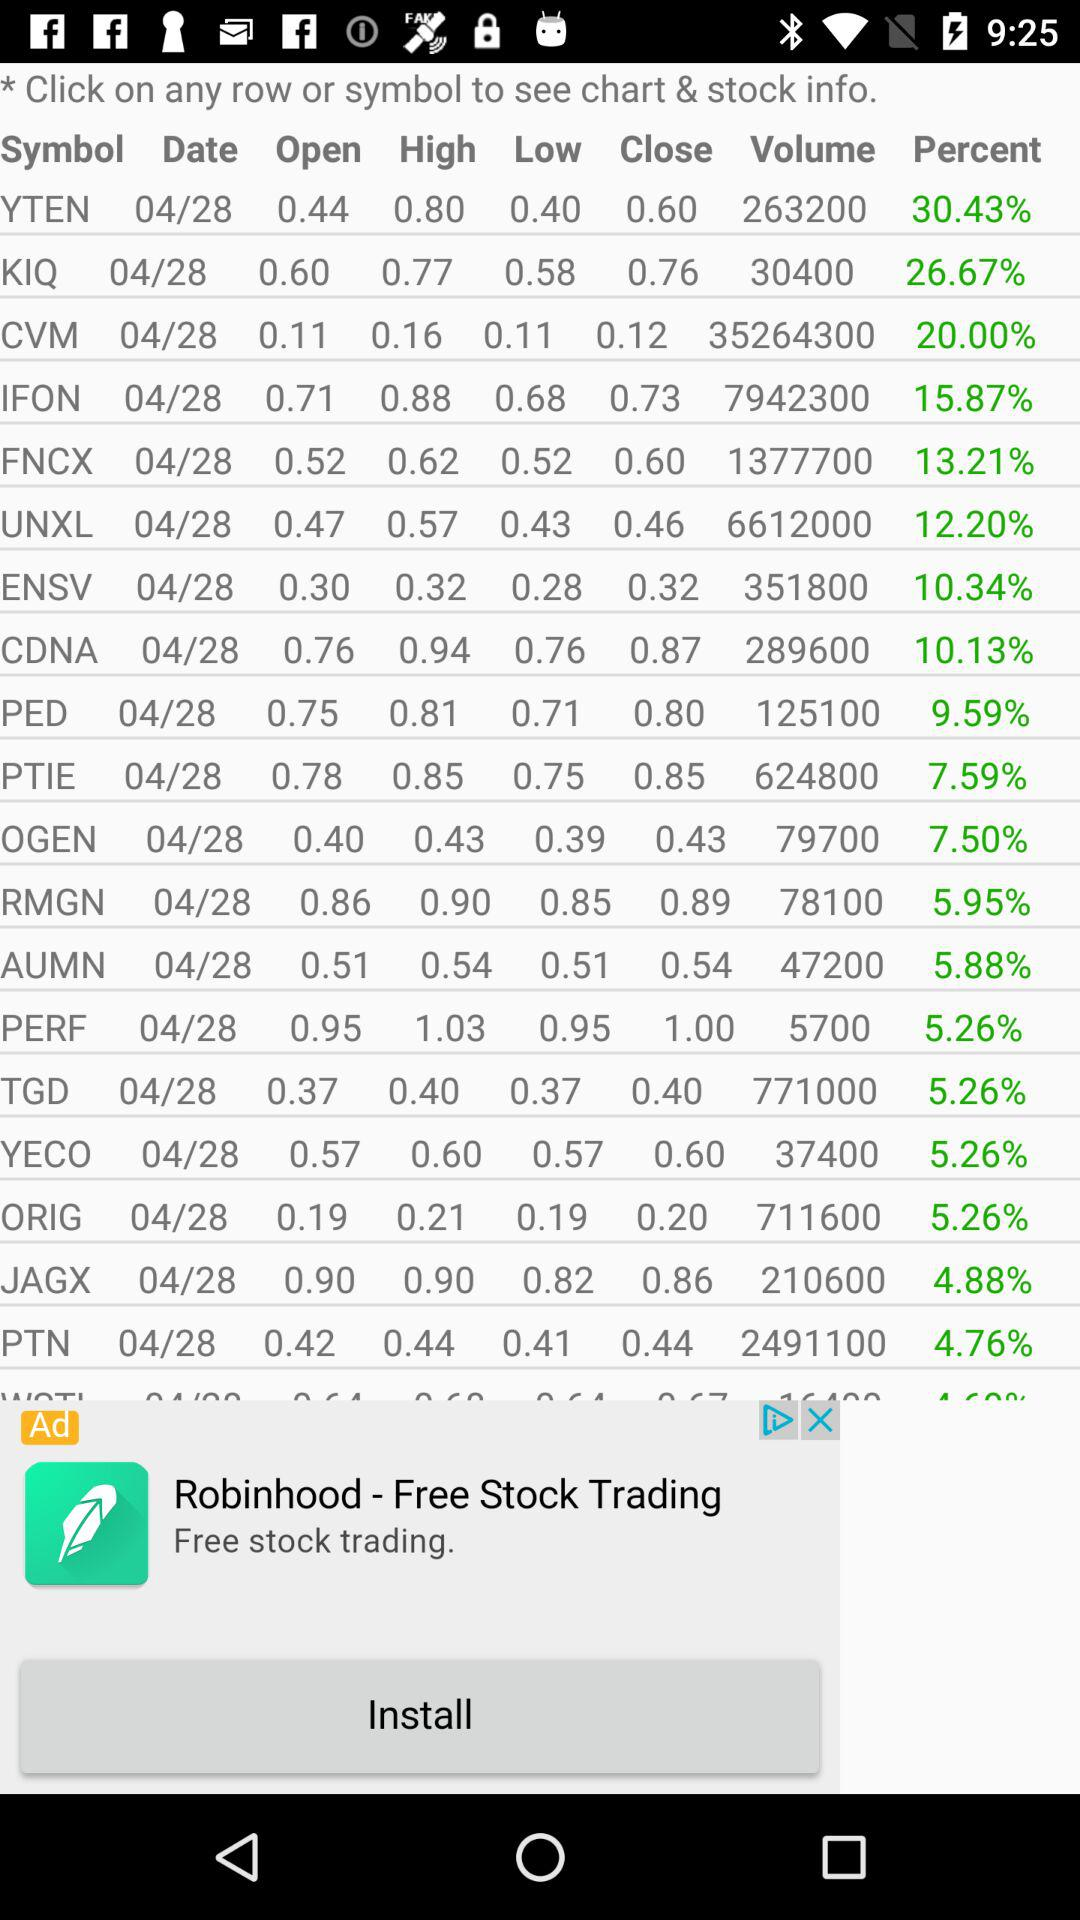What is the stock volume of IFON? The stock volume of IFON is 7942300. 